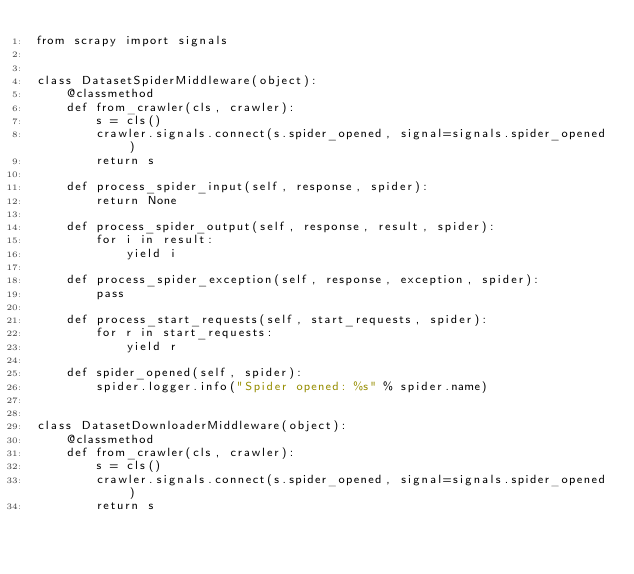Convert code to text. <code><loc_0><loc_0><loc_500><loc_500><_Python_>from scrapy import signals


class DatasetSpiderMiddleware(object):
    @classmethod
    def from_crawler(cls, crawler):
        s = cls()
        crawler.signals.connect(s.spider_opened, signal=signals.spider_opened)
        return s

    def process_spider_input(self, response, spider):
        return None

    def process_spider_output(self, response, result, spider):
        for i in result:
            yield i

    def process_spider_exception(self, response, exception, spider):
        pass

    def process_start_requests(self, start_requests, spider):
        for r in start_requests:
            yield r

    def spider_opened(self, spider):
        spider.logger.info("Spider opened: %s" % spider.name)


class DatasetDownloaderMiddleware(object):
    @classmethod
    def from_crawler(cls, crawler):
        s = cls()
        crawler.signals.connect(s.spider_opened, signal=signals.spider_opened)
        return s
</code> 